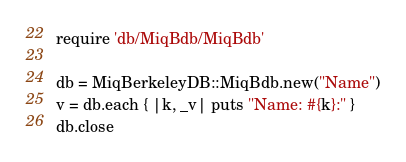Convert code to text. <code><loc_0><loc_0><loc_500><loc_500><_Ruby_>require 'db/MiqBdb/MiqBdb'

db = MiqBerkeleyDB::MiqBdb.new("Name")
v = db.each { |k, _v| puts "Name: #{k}:" }
db.close
</code> 